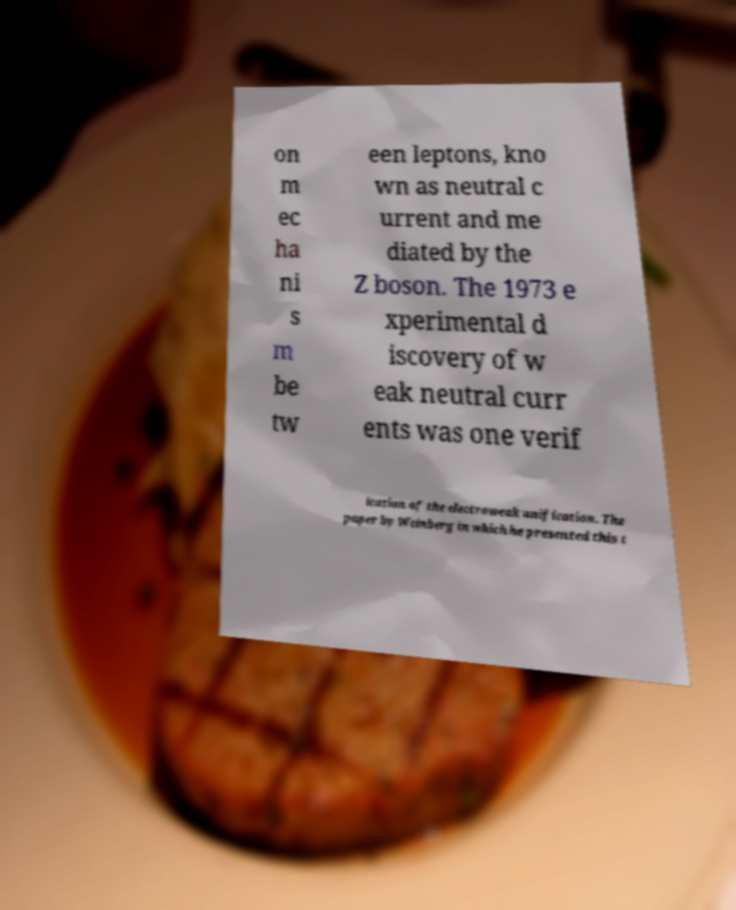Please read and relay the text visible in this image. What does it say? on m ec ha ni s m be tw een leptons, kno wn as neutral c urrent and me diated by the Z boson. The 1973 e xperimental d iscovery of w eak neutral curr ents was one verif ication of the electroweak unification. The paper by Weinberg in which he presented this t 